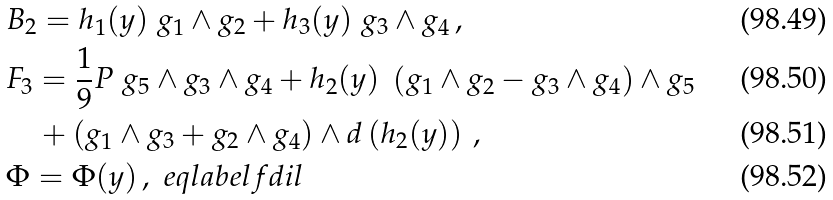Convert formula to latex. <formula><loc_0><loc_0><loc_500><loc_500>& B _ { 2 } = h _ { 1 } ( y ) \ g _ { 1 } \wedge g _ { 2 } + h _ { 3 } ( y ) \ g _ { 3 } \wedge g _ { 4 } \, , \\ & F _ { 3 } = \frac { 1 } { 9 } P \ g _ { 5 } \wedge g _ { 3 } \wedge g _ { 4 } + h _ { 2 } ( y ) \ \left ( g _ { 1 } \wedge g _ { 2 } - g _ { 3 } \wedge g _ { 4 } \right ) \wedge g _ { 5 } \\ & \quad + \left ( g _ { 1 } \wedge g _ { 3 } + g _ { 2 } \wedge g _ { 4 } \right ) \wedge d \left ( h _ { 2 } ( y ) \right ) \, , \\ & \Phi = \Phi ( y ) \, , \ e q l a b e l { f d i l }</formula> 